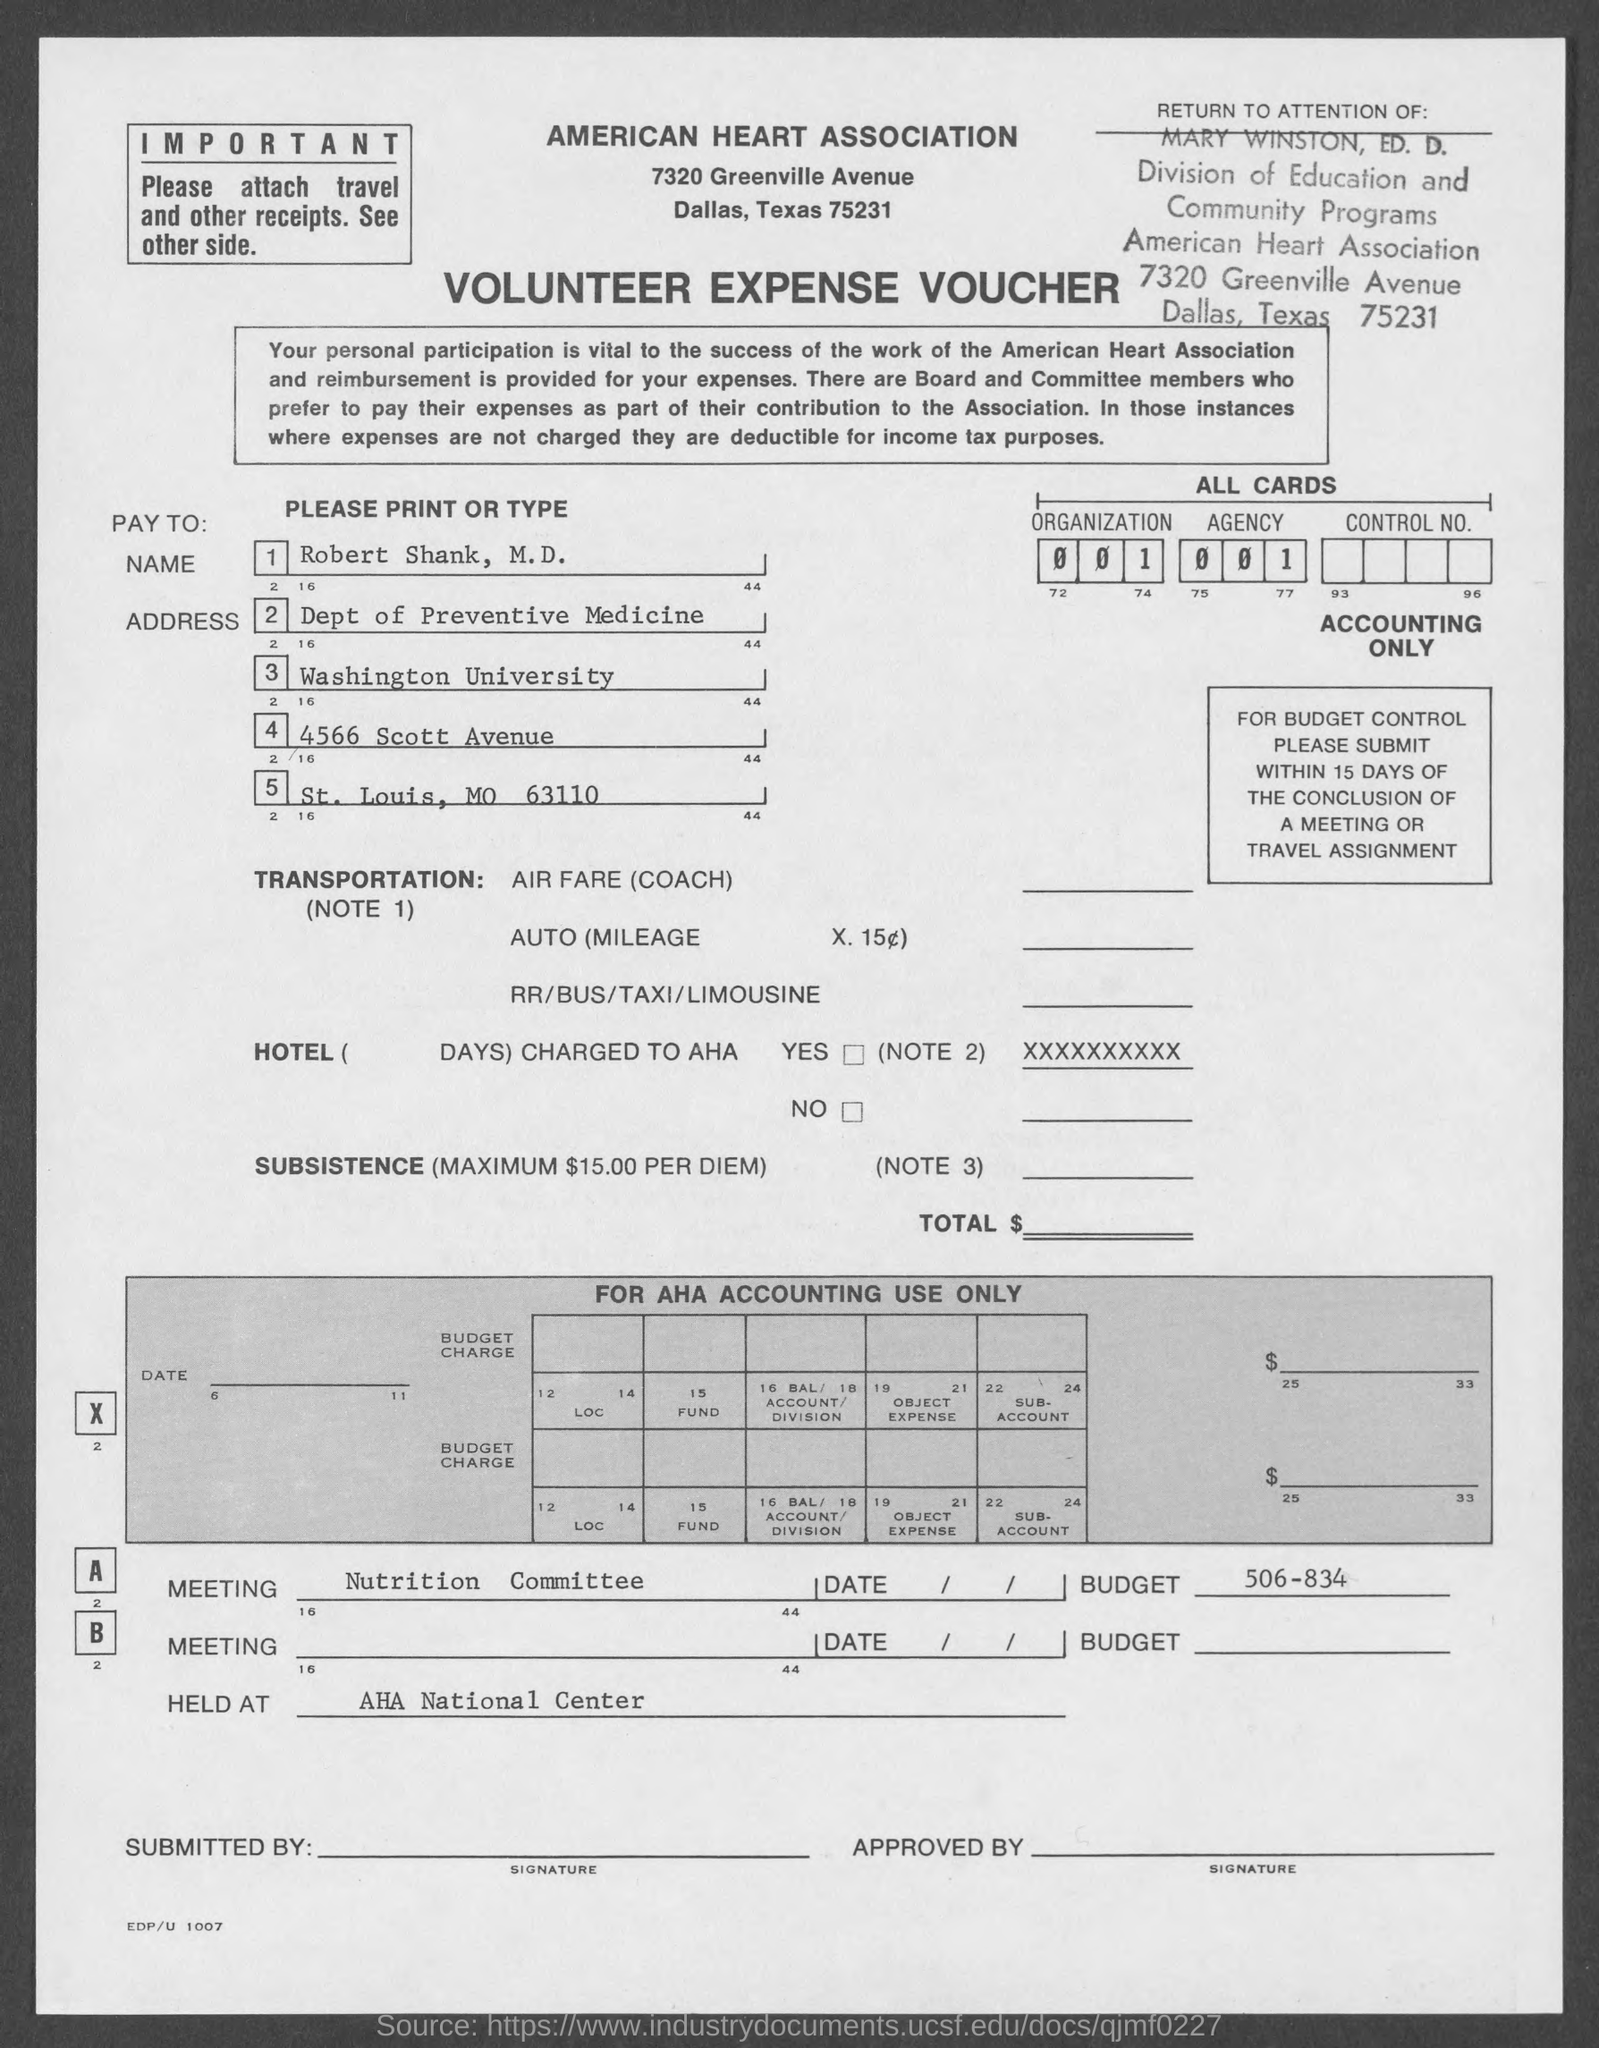What is written in the Meeting Field ?
Your response must be concise. Nutrition Committee. 